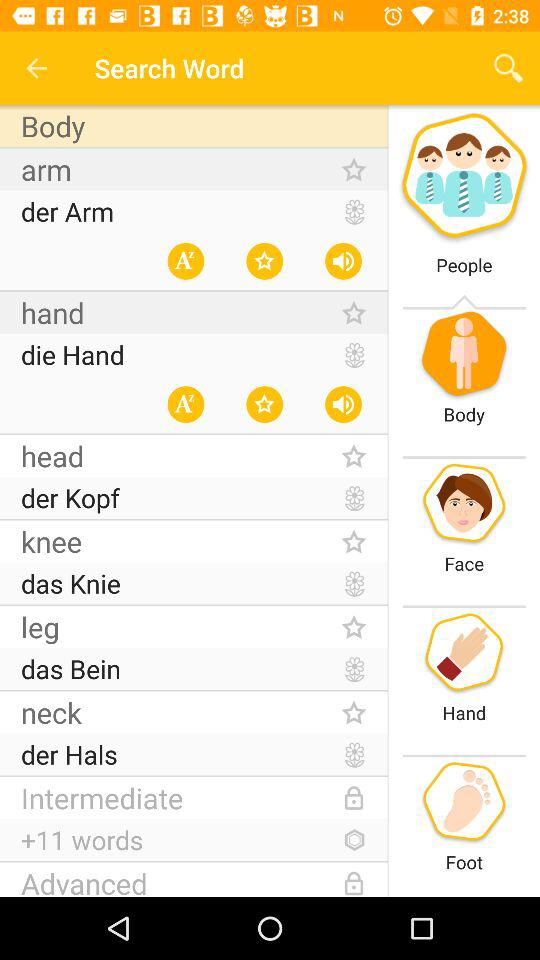How many words does "Intermediate" option have? It has 11 words. 